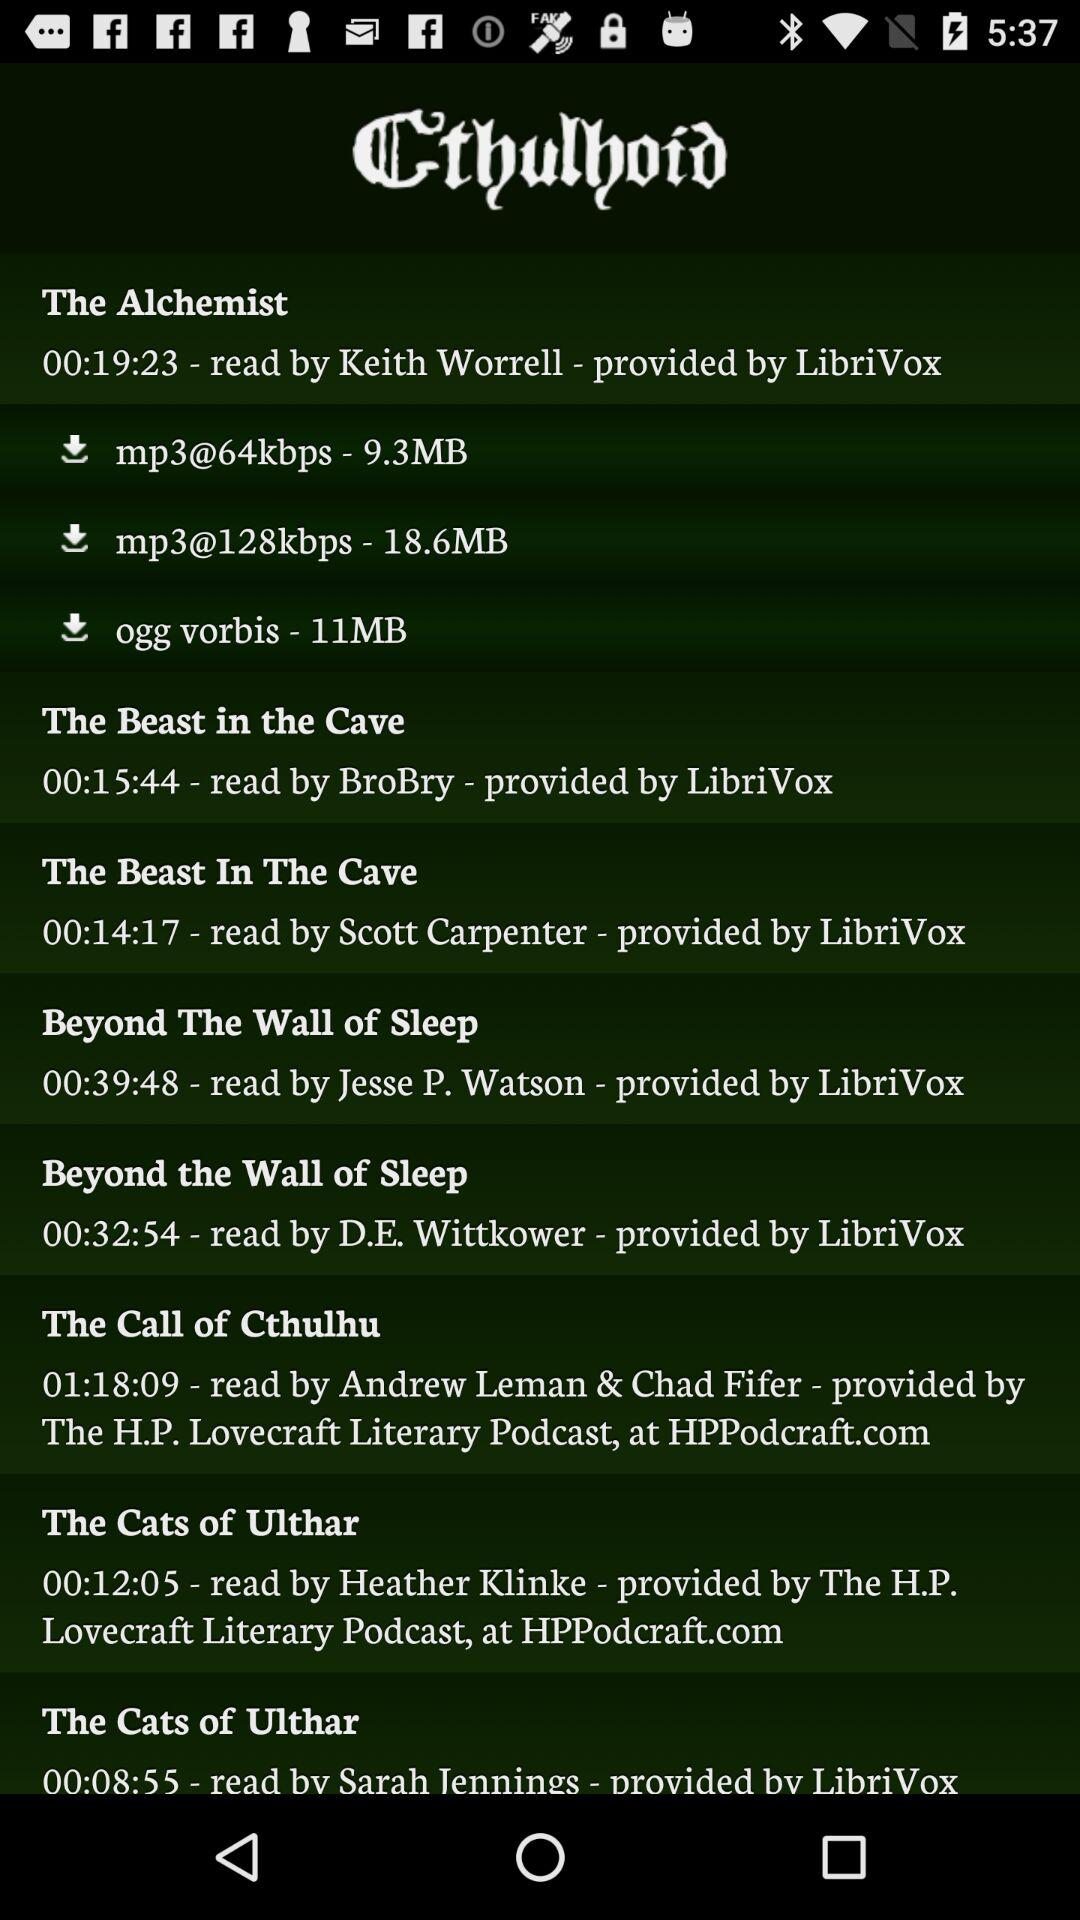What's the duration of "The Alchemist" audiobook? The duration of "The Alchemist" audiobook is 19 minutes 23 seconds. 